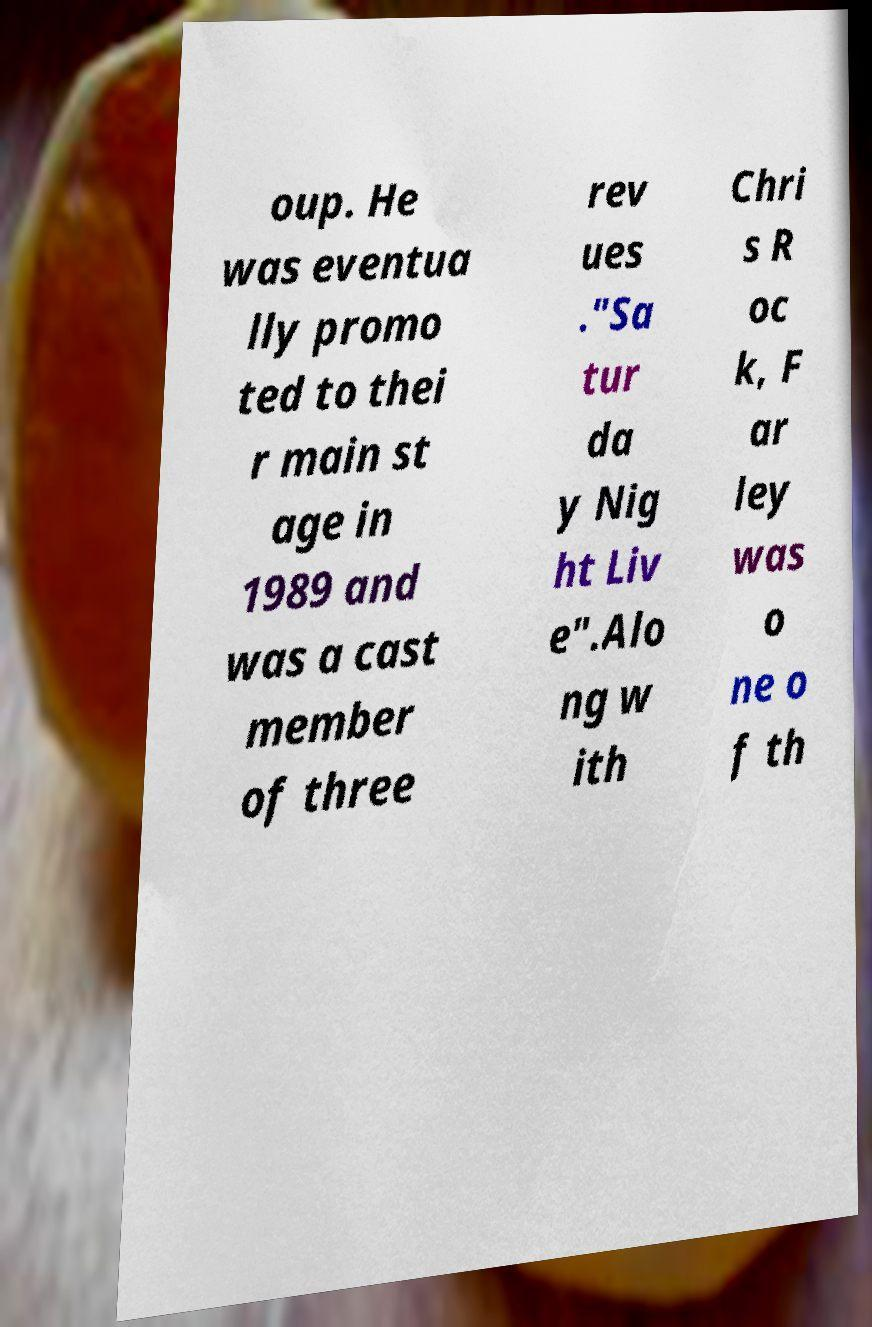Can you read and provide the text displayed in the image?This photo seems to have some interesting text. Can you extract and type it out for me? oup. He was eventua lly promo ted to thei r main st age in 1989 and was a cast member of three rev ues ."Sa tur da y Nig ht Liv e".Alo ng w ith Chri s R oc k, F ar ley was o ne o f th 